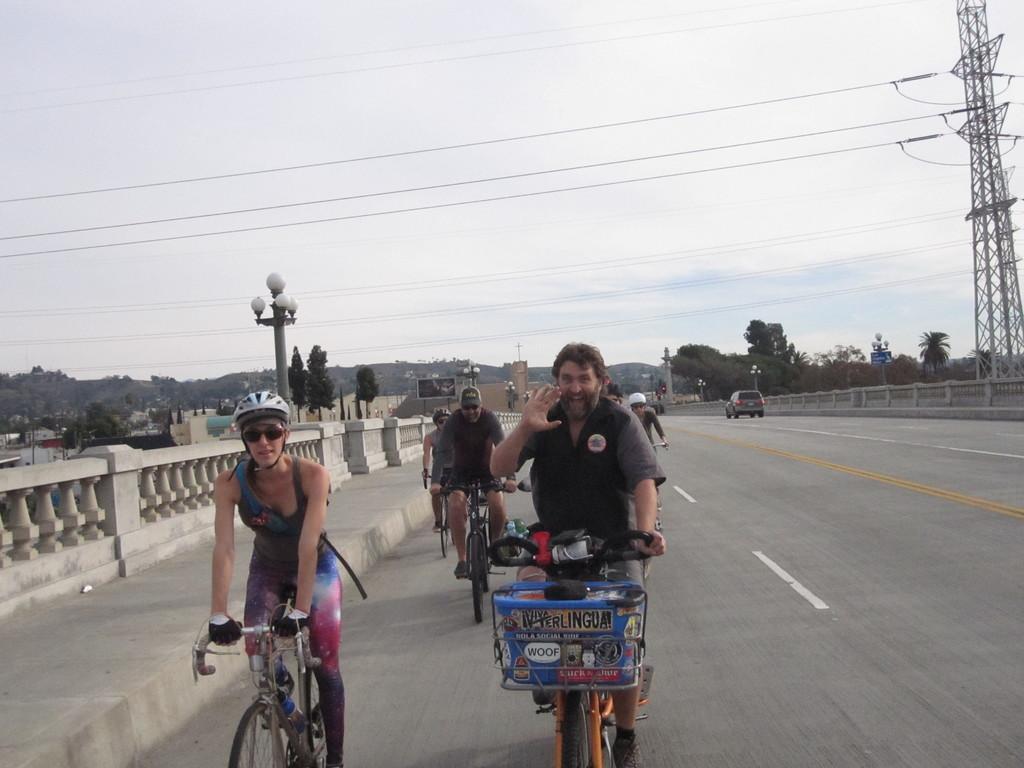Could you give a brief overview of what you see in this image? This picture is taken on the road of a city. On the top right there is a tower. In the background there are trees and hill. On the left there are buildings. In the center of the picture there is a road, on the road people are riding bicycles. Towards the left in the center there is a street light. 